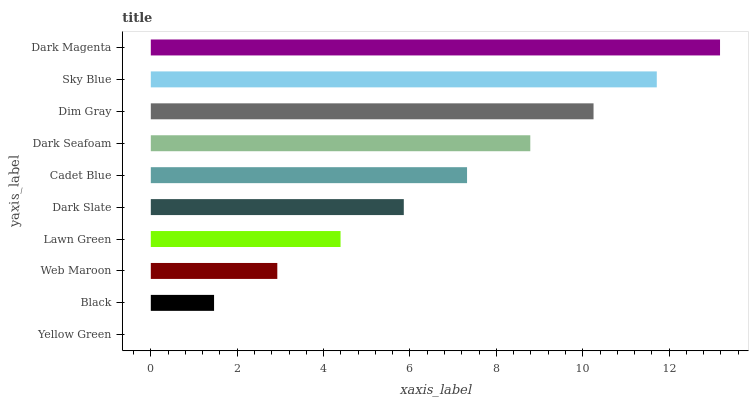Is Yellow Green the minimum?
Answer yes or no. Yes. Is Dark Magenta the maximum?
Answer yes or no. Yes. Is Black the minimum?
Answer yes or no. No. Is Black the maximum?
Answer yes or no. No. Is Black greater than Yellow Green?
Answer yes or no. Yes. Is Yellow Green less than Black?
Answer yes or no. Yes. Is Yellow Green greater than Black?
Answer yes or no. No. Is Black less than Yellow Green?
Answer yes or no. No. Is Cadet Blue the high median?
Answer yes or no. Yes. Is Dark Slate the low median?
Answer yes or no. Yes. Is Sky Blue the high median?
Answer yes or no. No. Is Lawn Green the low median?
Answer yes or no. No. 